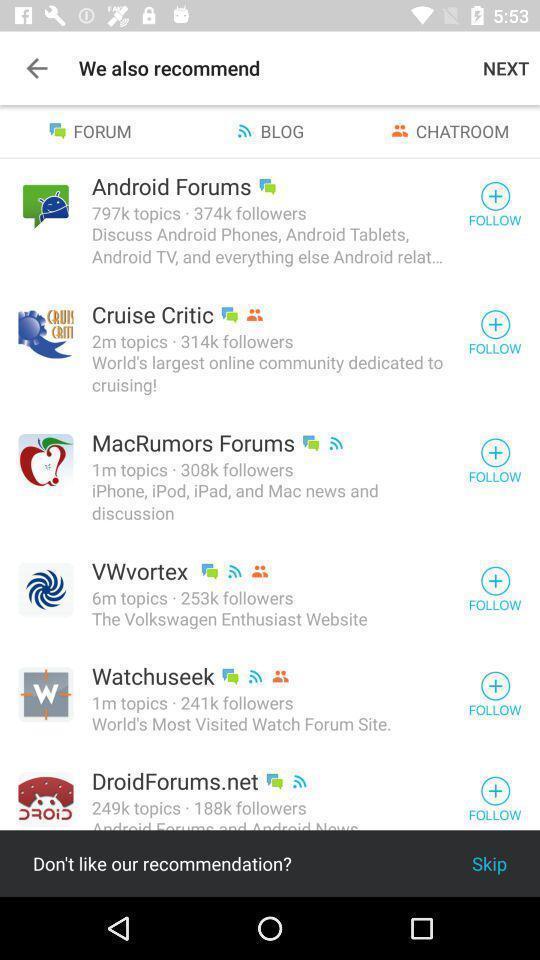Give me a summary of this screen capture. Screen displaying a list of online forums names. 